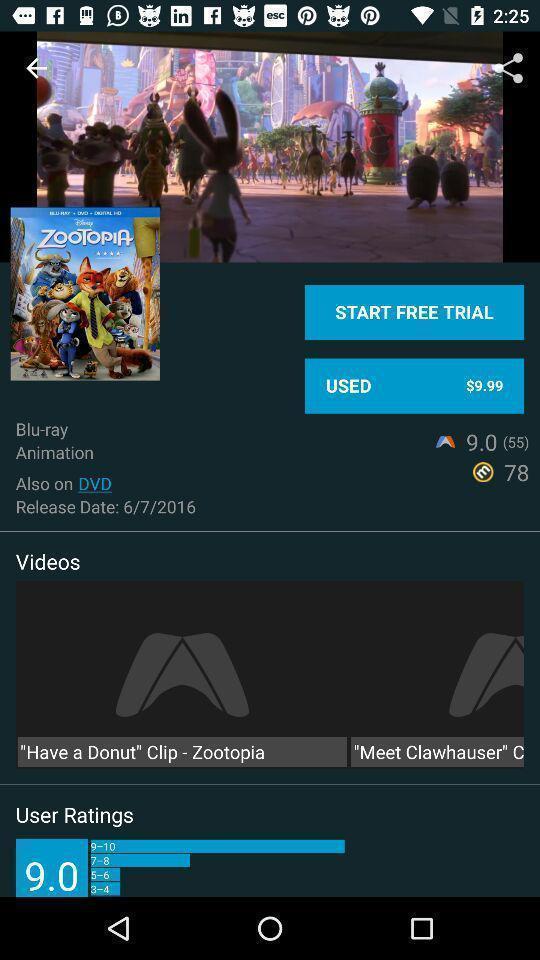Summarize the information in this screenshot. Screen showing about the movie in a streaming app. 